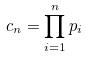<formula> <loc_0><loc_0><loc_500><loc_500>c _ { n } = \prod _ { i = 1 } ^ { n } p _ { i }</formula> 